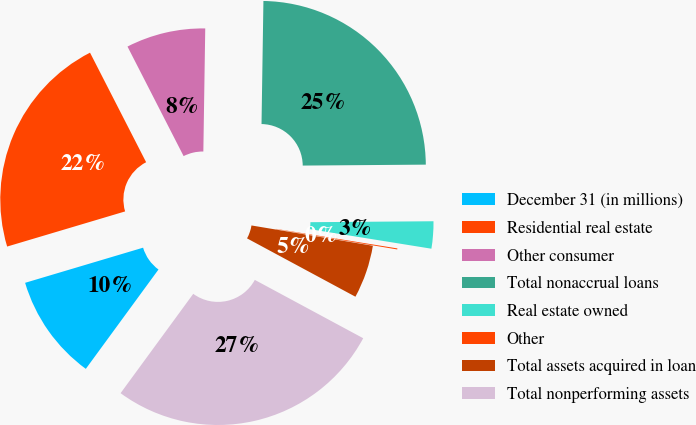<chart> <loc_0><loc_0><loc_500><loc_500><pie_chart><fcel>December 31 (in millions)<fcel>Residential real estate<fcel>Other consumer<fcel>Total nonaccrual loans<fcel>Real estate owned<fcel>Other<fcel>Total assets acquired in loan<fcel>Total nonperforming assets<nl><fcel>10.34%<fcel>22.07%<fcel>7.78%<fcel>24.63%<fcel>2.66%<fcel>0.1%<fcel>5.22%<fcel>27.19%<nl></chart> 